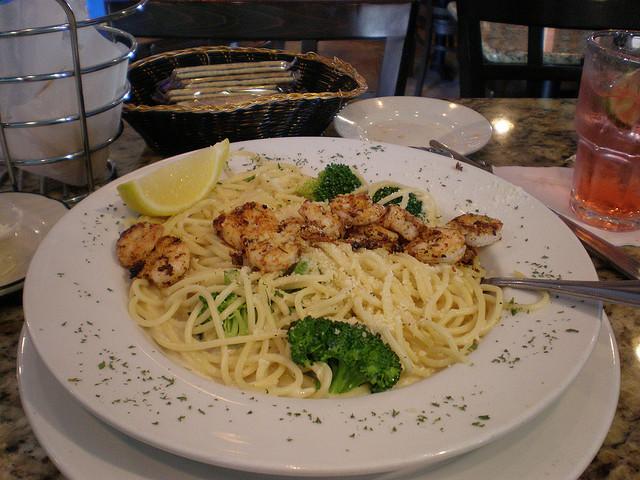What is the name of this dessert?
Be succinct. Pasta. Is the plate made of paper?
Answer briefly. No. Is there  falafel on the table?
Give a very brief answer. No. How many candles are illuminated?
Answer briefly. 0. What has the plate been garnished with?
Keep it brief. Parsley. Does this meal have pork in it?
Quick response, please. No. Is this food good for a luncheon?
Concise answer only. Yes. Is this too much pasta for you?
Give a very brief answer. No. What kind of food is shown?
Answer briefly. Pasta. 